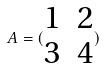Convert formula to latex. <formula><loc_0><loc_0><loc_500><loc_500>A = ( \begin{matrix} 1 & 2 \\ 3 & 4 \end{matrix} )</formula> 